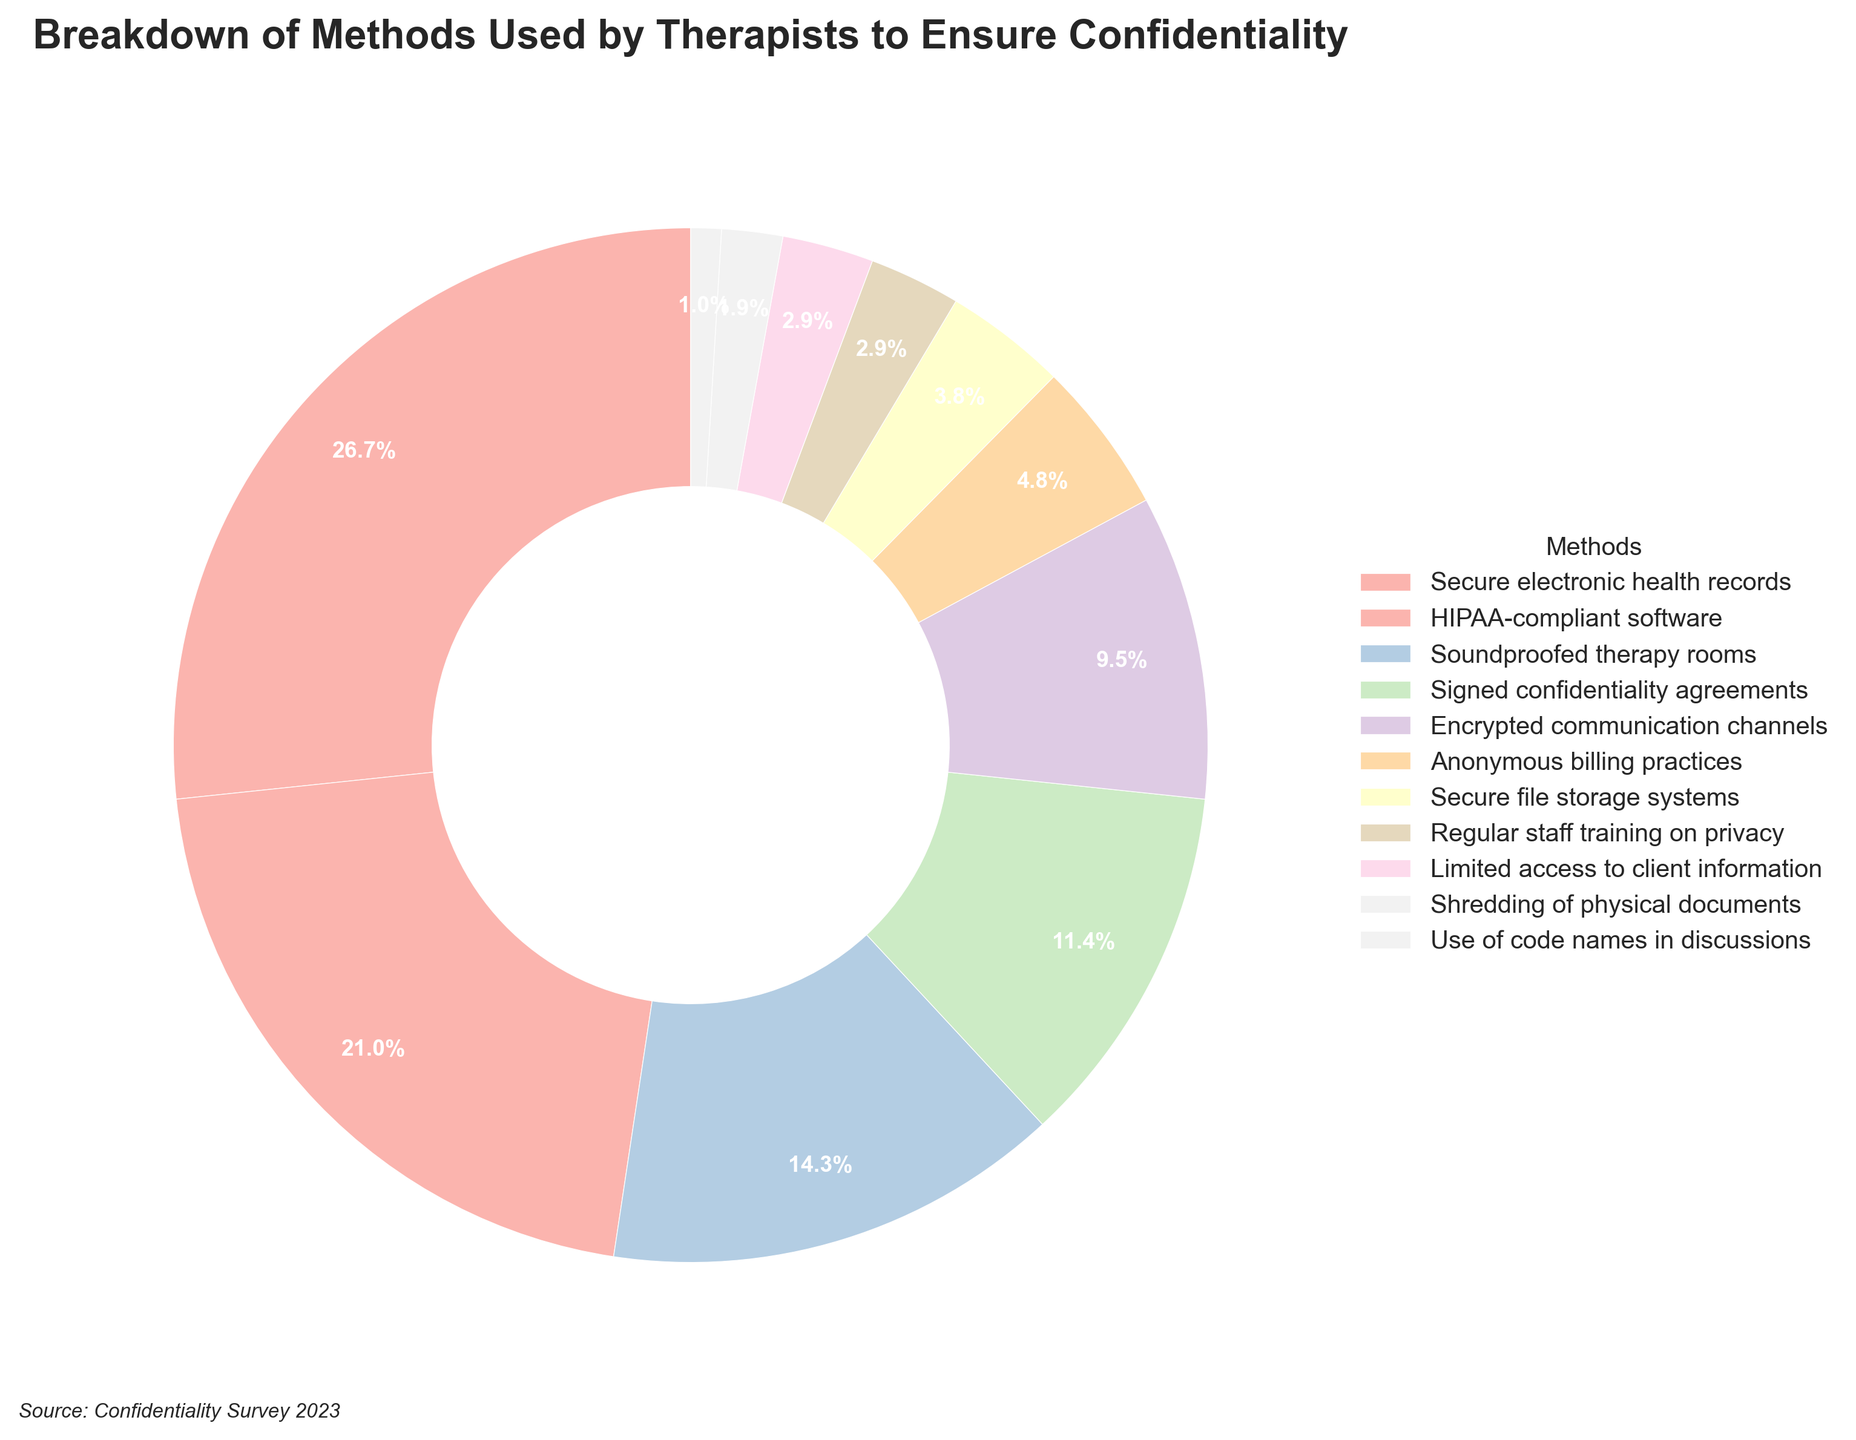What is the total percentage of methods used by therapists to ensure confidentiality related to electronic systems? We need to add the percentages of methods that use electronic systems: Secure electronic health records (28%), HIPAA-compliant software (22%), Encrypted communication channels (10%), and Secure file storage systems (4%). 28 + 22 + 10 + 4 = 64%
Answer: 64% Which method ranks the highest in ensuring confidentiality? Look at the figure and find the method with the largest percentage. Secure electronic health records have the highest percentage, 28%.
Answer: Secure electronic health records Are anonymized billing practices more or less utilized than regular staff training on privacy? Compare the percentages: Anonymous billing practices have 5% and regular staff training on privacy has 3%. Since 5% > 3%, anonymous billing practices are more utilized.
Answer: More utilized What is the least utilized method for ensuring confidentiality? Look for the smallest segment in the chart which corresponds to the method, Use of code names in discussions, at 1%.
Answer: Use of code names in discussions What is the combined percentage of soundproofed therapy rooms and signed confidentiality agreements? Add the percentages of soundproofed therapy rooms (15%) and signed confidentiality agreements (12%): 15 + 12 = 27%
Answer: 27% How does encrypted communication channels compare with anonymous billing practices? Compare the percentages of both methods: Encrypted communication channels have 10% while anonymous billing practices have 5%. Since 10% > 5%, encrypted communication channels are more utilized.
Answer: More utilized Which methods make up less than 5% each of the total methods used by therapists? Identify the methods with percentages less than 5%: Secure file storage systems (4%), Regular staff training on privacy (3%), Limited access to client information (3%), Shredding of physical documents (2%), and Use of code names in discussions (1%).
Answer: Secure file storage systems, Regular staff training on privacy, Limited access to client information, Shredding of physical documents, Use of code names in discussions How many more percentage points do HIPAA-compliant software have compared to shredded physical documents? Subtract the percentage of shredded physical documents (2%) from HIPAA-compliant software (22%): 22 - 2 = 20 percentage points.
Answer: 20 percentage points What is the third most common method used by therapists to ensure confidentiality? Identify the methods and their percentages; the third largest value is 15%, which corresponds to soundproofed therapy rooms.
Answer: Soundproofed therapy rooms 